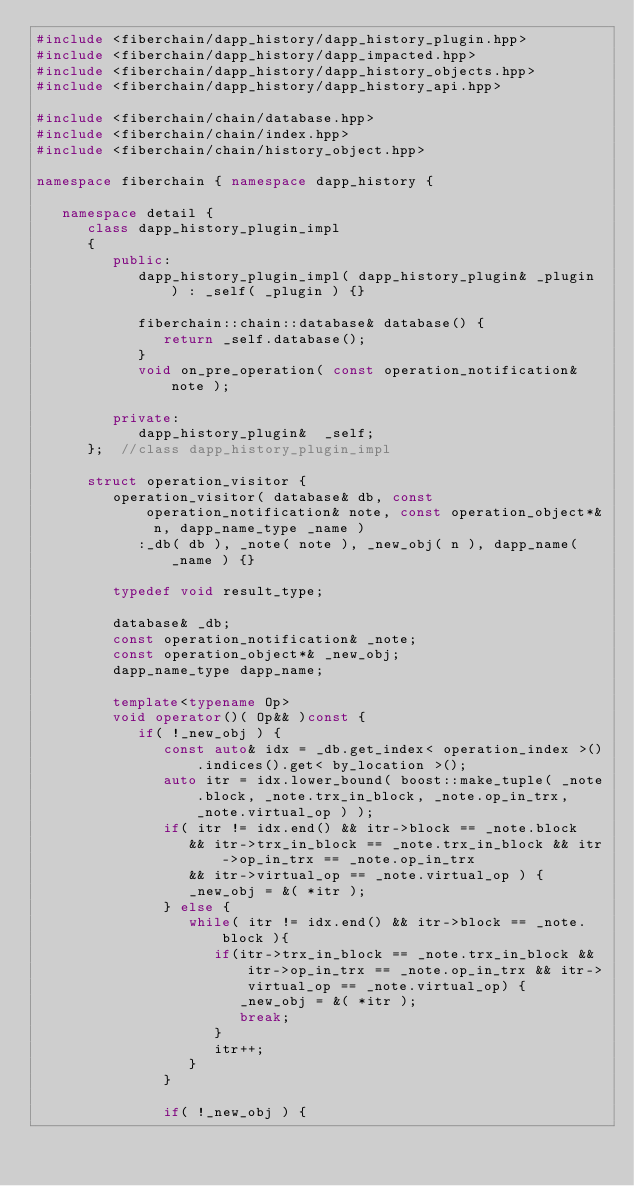Convert code to text. <code><loc_0><loc_0><loc_500><loc_500><_C++_>#include <fiberchain/dapp_history/dapp_history_plugin.hpp>
#include <fiberchain/dapp_history/dapp_impacted.hpp>
#include <fiberchain/dapp_history/dapp_history_objects.hpp>
#include <fiberchain/dapp_history/dapp_history_api.hpp>

#include <fiberchain/chain/database.hpp>
#include <fiberchain/chain/index.hpp>
#include <fiberchain/chain/history_object.hpp>

namespace fiberchain { namespace dapp_history {

   namespace detail {
      class dapp_history_plugin_impl
      {
         public:
            dapp_history_plugin_impl( dapp_history_plugin& _plugin ) : _self( _plugin ) {}

            fiberchain::chain::database& database() {
               return _self.database();
            }
            void on_pre_operation( const operation_notification& note );

         private:
            dapp_history_plugin&  _self;
      };  //class dapp_history_plugin_impl

      struct operation_visitor {
         operation_visitor( database& db, const operation_notification& note, const operation_object*& n, dapp_name_type _name )
            :_db( db ), _note( note ), _new_obj( n ), dapp_name( _name ) {}

         typedef void result_type;

         database& _db;
         const operation_notification& _note;
         const operation_object*& _new_obj;
         dapp_name_type dapp_name;

         template<typename Op>
         void operator()( Op&& )const {
            if( !_new_obj ) {
               const auto& idx = _db.get_index< operation_index >().indices().get< by_location >();
               auto itr = idx.lower_bound( boost::make_tuple( _note.block, _note.trx_in_block, _note.op_in_trx, _note.virtual_op ) );
               if( itr != idx.end() && itr->block == _note.block 
                  && itr->trx_in_block == _note.trx_in_block && itr->op_in_trx == _note.op_in_trx
                  && itr->virtual_op == _note.virtual_op ) {
                  _new_obj = &( *itr );
               } else {
                  while( itr != idx.end() && itr->block == _note.block ){
                     if(itr->trx_in_block == _note.trx_in_block && itr->op_in_trx == _note.op_in_trx && itr->virtual_op == _note.virtual_op) {
                        _new_obj = &( *itr );
                        break;
                     }
                     itr++;
                  }
               }

               if( !_new_obj ) {</code> 